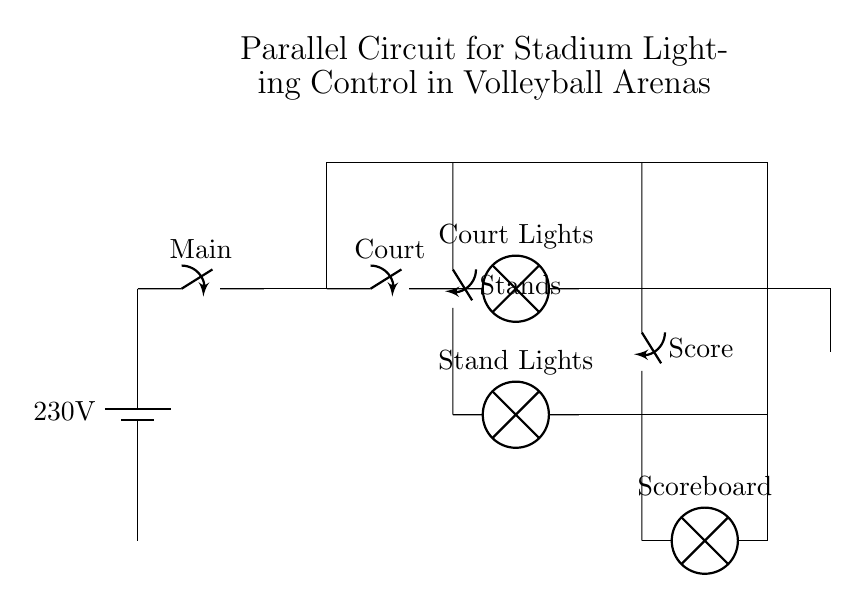What is the voltage supplied to the circuit? The circuit is powered by a battery labeled with 230 volts, indicating the voltage supplied to the entire circuit.
Answer: 230 volts What components are present in the Court Lighting branch? The Court Lighting branch consists of a switch labeled "Court" and a lamp labeled "Court Lights." This identifies the specific components that control and illuminate the volleyball court area.
Answer: Switch and lamp How many lighting branches are in this circuit? The circuit has three distinct branches: Court Lighting, Stands Lighting, and Scoreboard. This is counted by looking at the components connected in parallel from the main line.
Answer: Three What is the function of the main switch? The main switch controls the entire circuit, allowing or stopping the flow of electricity to all branches at once. This is indicated by its placement at the start of the circuit, before the branches split.
Answer: To control the entire circuit Which branch is responsible for illuminating the stands? The branch labeled "Stands" is responsible for providing lighting specifically to the spectator stands in the arena. You can deduce this by identifying the label associated with that branch.
Answer: Stands Lighting If the Court Lighting is turned off, what happens to the other lights? Since the circuit is parallel, the other branches (like Stands Lighting and Scoreboard) continue to function independently when one branch, like Court Lighting, is turned off. This illustrates the characteristic behavior of parallel circuits where other paths remain operational.
Answer: Other lights remain on 